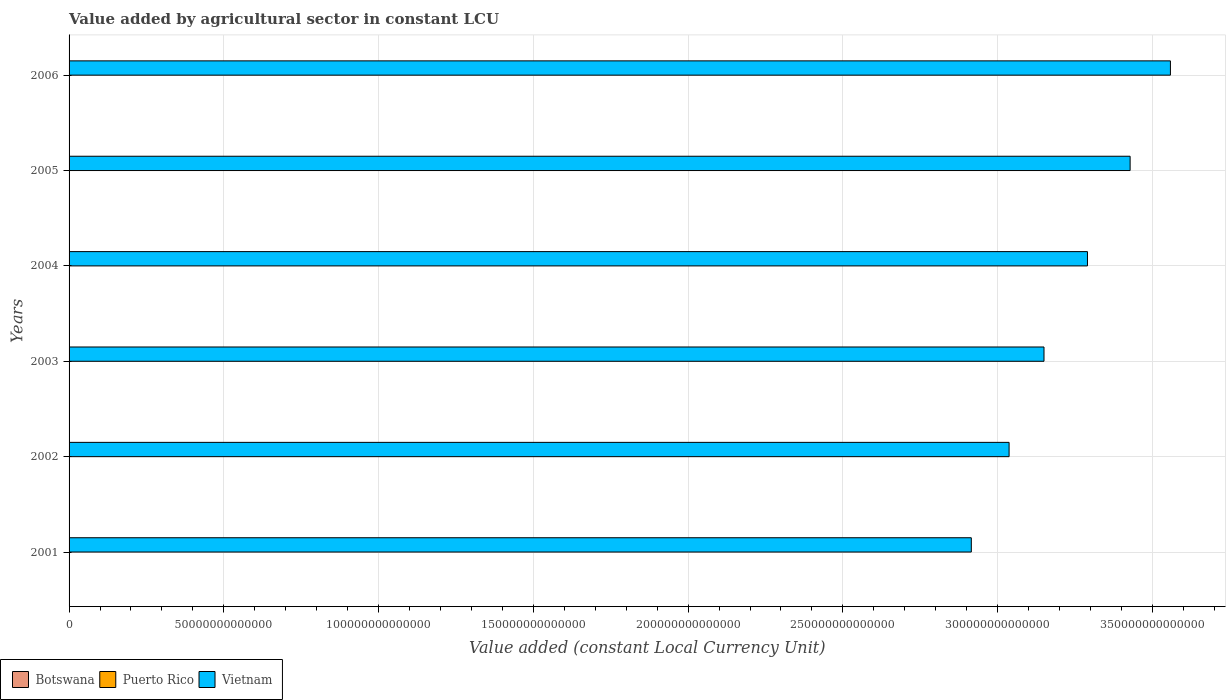Are the number of bars on each tick of the Y-axis equal?
Provide a short and direct response. Yes. What is the label of the 4th group of bars from the top?
Offer a very short reply. 2003. What is the value added by agricultural sector in Vietnam in 2006?
Give a very brief answer. 3.56e+14. Across all years, what is the maximum value added by agricultural sector in Vietnam?
Offer a very short reply. 3.56e+14. Across all years, what is the minimum value added by agricultural sector in Puerto Rico?
Your answer should be compact. 1.13e+08. In which year was the value added by agricultural sector in Vietnam maximum?
Provide a succinct answer. 2006. In which year was the value added by agricultural sector in Puerto Rico minimum?
Give a very brief answer. 2002. What is the total value added by agricultural sector in Vietnam in the graph?
Offer a very short reply. 1.94e+15. What is the difference between the value added by agricultural sector in Vietnam in 2004 and that in 2006?
Offer a terse response. -2.68e+13. What is the difference between the value added by agricultural sector in Puerto Rico in 2001 and the value added by agricultural sector in Vietnam in 2003?
Ensure brevity in your answer.  -3.15e+14. What is the average value added by agricultural sector in Puerto Rico per year?
Ensure brevity in your answer.  1.41e+08. In the year 2002, what is the difference between the value added by agricultural sector in Botswana and value added by agricultural sector in Puerto Rico?
Offer a terse response. 7.95e+08. In how many years, is the value added by agricultural sector in Botswana greater than 320000000000000 LCU?
Your answer should be compact. 0. What is the ratio of the value added by agricultural sector in Botswana in 2003 to that in 2006?
Your answer should be very brief. 0.9. Is the value added by agricultural sector in Botswana in 2003 less than that in 2004?
Ensure brevity in your answer.  Yes. What is the difference between the highest and the second highest value added by agricultural sector in Puerto Rico?
Make the answer very short. 1.14e+07. What is the difference between the highest and the lowest value added by agricultural sector in Puerto Rico?
Provide a short and direct response. 4.76e+07. Is the sum of the value added by agricultural sector in Puerto Rico in 2001 and 2005 greater than the maximum value added by agricultural sector in Botswana across all years?
Keep it short and to the point. No. What does the 1st bar from the top in 2006 represents?
Ensure brevity in your answer.  Vietnam. What does the 3rd bar from the bottom in 2004 represents?
Offer a terse response. Vietnam. How many bars are there?
Offer a very short reply. 18. How many years are there in the graph?
Your answer should be compact. 6. What is the difference between two consecutive major ticks on the X-axis?
Make the answer very short. 5.00e+13. Are the values on the major ticks of X-axis written in scientific E-notation?
Offer a terse response. No. Where does the legend appear in the graph?
Keep it short and to the point. Bottom left. How many legend labels are there?
Give a very brief answer. 3. How are the legend labels stacked?
Your answer should be very brief. Horizontal. What is the title of the graph?
Give a very brief answer. Value added by agricultural sector in constant LCU. Does "Burundi" appear as one of the legend labels in the graph?
Ensure brevity in your answer.  No. What is the label or title of the X-axis?
Offer a terse response. Value added (constant Local Currency Unit). What is the Value added (constant Local Currency Unit) of Botswana in 2001?
Make the answer very short. 1.14e+09. What is the Value added (constant Local Currency Unit) in Puerto Rico in 2001?
Provide a short and direct response. 1.41e+08. What is the Value added (constant Local Currency Unit) of Vietnam in 2001?
Keep it short and to the point. 2.92e+14. What is the Value added (constant Local Currency Unit) in Botswana in 2002?
Ensure brevity in your answer.  9.08e+08. What is the Value added (constant Local Currency Unit) of Puerto Rico in 2002?
Offer a very short reply. 1.13e+08. What is the Value added (constant Local Currency Unit) in Vietnam in 2002?
Give a very brief answer. 3.04e+14. What is the Value added (constant Local Currency Unit) of Botswana in 2003?
Your response must be concise. 1.09e+09. What is the Value added (constant Local Currency Unit) of Puerto Rico in 2003?
Offer a terse response. 1.30e+08. What is the Value added (constant Local Currency Unit) of Vietnam in 2003?
Your answer should be very brief. 3.15e+14. What is the Value added (constant Local Currency Unit) in Botswana in 2004?
Your answer should be very brief. 1.10e+09. What is the Value added (constant Local Currency Unit) of Puerto Rico in 2004?
Provide a short and direct response. 1.61e+08. What is the Value added (constant Local Currency Unit) of Vietnam in 2004?
Keep it short and to the point. 3.29e+14. What is the Value added (constant Local Currency Unit) in Botswana in 2005?
Provide a short and direct response. 1.07e+09. What is the Value added (constant Local Currency Unit) in Puerto Rico in 2005?
Make the answer very short. 1.49e+08. What is the Value added (constant Local Currency Unit) in Vietnam in 2005?
Provide a succinct answer. 3.43e+14. What is the Value added (constant Local Currency Unit) in Botswana in 2006?
Your answer should be compact. 1.21e+09. What is the Value added (constant Local Currency Unit) in Puerto Rico in 2006?
Give a very brief answer. 1.50e+08. What is the Value added (constant Local Currency Unit) in Vietnam in 2006?
Provide a short and direct response. 3.56e+14. Across all years, what is the maximum Value added (constant Local Currency Unit) of Botswana?
Make the answer very short. 1.21e+09. Across all years, what is the maximum Value added (constant Local Currency Unit) in Puerto Rico?
Your response must be concise. 1.61e+08. Across all years, what is the maximum Value added (constant Local Currency Unit) in Vietnam?
Offer a very short reply. 3.56e+14. Across all years, what is the minimum Value added (constant Local Currency Unit) of Botswana?
Provide a succinct answer. 9.08e+08. Across all years, what is the minimum Value added (constant Local Currency Unit) of Puerto Rico?
Your response must be concise. 1.13e+08. Across all years, what is the minimum Value added (constant Local Currency Unit) of Vietnam?
Offer a terse response. 2.92e+14. What is the total Value added (constant Local Currency Unit) in Botswana in the graph?
Provide a succinct answer. 6.52e+09. What is the total Value added (constant Local Currency Unit) of Puerto Rico in the graph?
Offer a terse response. 8.43e+08. What is the total Value added (constant Local Currency Unit) in Vietnam in the graph?
Provide a short and direct response. 1.94e+15. What is the difference between the Value added (constant Local Currency Unit) in Botswana in 2001 and that in 2002?
Provide a short and direct response. 2.34e+08. What is the difference between the Value added (constant Local Currency Unit) of Puerto Rico in 2001 and that in 2002?
Keep it short and to the point. 2.76e+07. What is the difference between the Value added (constant Local Currency Unit) of Vietnam in 2001 and that in 2002?
Offer a very short reply. -1.22e+13. What is the difference between the Value added (constant Local Currency Unit) of Botswana in 2001 and that in 2003?
Ensure brevity in your answer.  5.12e+07. What is the difference between the Value added (constant Local Currency Unit) in Puerto Rico in 2001 and that in 2003?
Provide a succinct answer. 1.14e+07. What is the difference between the Value added (constant Local Currency Unit) of Vietnam in 2001 and that in 2003?
Provide a short and direct response. -2.35e+13. What is the difference between the Value added (constant Local Currency Unit) of Botswana in 2001 and that in 2004?
Offer a very short reply. 4.60e+07. What is the difference between the Value added (constant Local Currency Unit) of Puerto Rico in 2001 and that in 2004?
Provide a short and direct response. -2.00e+07. What is the difference between the Value added (constant Local Currency Unit) in Vietnam in 2001 and that in 2004?
Ensure brevity in your answer.  -3.75e+13. What is the difference between the Value added (constant Local Currency Unit) in Botswana in 2001 and that in 2005?
Give a very brief answer. 7.35e+07. What is the difference between the Value added (constant Local Currency Unit) of Puerto Rico in 2001 and that in 2005?
Provide a short and direct response. -7.62e+06. What is the difference between the Value added (constant Local Currency Unit) of Vietnam in 2001 and that in 2005?
Your response must be concise. -5.13e+13. What is the difference between the Value added (constant Local Currency Unit) in Botswana in 2001 and that in 2006?
Make the answer very short. -6.89e+07. What is the difference between the Value added (constant Local Currency Unit) in Puerto Rico in 2001 and that in 2006?
Ensure brevity in your answer.  -8.58e+06. What is the difference between the Value added (constant Local Currency Unit) of Vietnam in 2001 and that in 2006?
Provide a short and direct response. -6.43e+13. What is the difference between the Value added (constant Local Currency Unit) of Botswana in 2002 and that in 2003?
Offer a terse response. -1.83e+08. What is the difference between the Value added (constant Local Currency Unit) in Puerto Rico in 2002 and that in 2003?
Provide a short and direct response. -1.62e+07. What is the difference between the Value added (constant Local Currency Unit) of Vietnam in 2002 and that in 2003?
Make the answer very short. -1.13e+13. What is the difference between the Value added (constant Local Currency Unit) in Botswana in 2002 and that in 2004?
Keep it short and to the point. -1.88e+08. What is the difference between the Value added (constant Local Currency Unit) of Puerto Rico in 2002 and that in 2004?
Ensure brevity in your answer.  -4.76e+07. What is the difference between the Value added (constant Local Currency Unit) of Vietnam in 2002 and that in 2004?
Make the answer very short. -2.53e+13. What is the difference between the Value added (constant Local Currency Unit) of Botswana in 2002 and that in 2005?
Provide a short and direct response. -1.60e+08. What is the difference between the Value added (constant Local Currency Unit) in Puerto Rico in 2002 and that in 2005?
Make the answer very short. -3.53e+07. What is the difference between the Value added (constant Local Currency Unit) in Vietnam in 2002 and that in 2005?
Keep it short and to the point. -3.91e+13. What is the difference between the Value added (constant Local Currency Unit) in Botswana in 2002 and that in 2006?
Ensure brevity in your answer.  -3.03e+08. What is the difference between the Value added (constant Local Currency Unit) of Puerto Rico in 2002 and that in 2006?
Offer a terse response. -3.62e+07. What is the difference between the Value added (constant Local Currency Unit) of Vietnam in 2002 and that in 2006?
Make the answer very short. -5.21e+13. What is the difference between the Value added (constant Local Currency Unit) in Botswana in 2003 and that in 2004?
Provide a succinct answer. -5.15e+06. What is the difference between the Value added (constant Local Currency Unit) of Puerto Rico in 2003 and that in 2004?
Offer a terse response. -3.14e+07. What is the difference between the Value added (constant Local Currency Unit) in Vietnam in 2003 and that in 2004?
Your answer should be very brief. -1.40e+13. What is the difference between the Value added (constant Local Currency Unit) in Botswana in 2003 and that in 2005?
Make the answer very short. 2.23e+07. What is the difference between the Value added (constant Local Currency Unit) of Puerto Rico in 2003 and that in 2005?
Provide a succinct answer. -1.91e+07. What is the difference between the Value added (constant Local Currency Unit) in Vietnam in 2003 and that in 2005?
Offer a terse response. -2.78e+13. What is the difference between the Value added (constant Local Currency Unit) in Botswana in 2003 and that in 2006?
Provide a succinct answer. -1.20e+08. What is the difference between the Value added (constant Local Currency Unit) in Puerto Rico in 2003 and that in 2006?
Your response must be concise. -2.00e+07. What is the difference between the Value added (constant Local Currency Unit) in Vietnam in 2003 and that in 2006?
Make the answer very short. -4.08e+13. What is the difference between the Value added (constant Local Currency Unit) of Botswana in 2004 and that in 2005?
Provide a succinct answer. 2.74e+07. What is the difference between the Value added (constant Local Currency Unit) of Puerto Rico in 2004 and that in 2005?
Provide a succinct answer. 1.24e+07. What is the difference between the Value added (constant Local Currency Unit) of Vietnam in 2004 and that in 2005?
Give a very brief answer. -1.38e+13. What is the difference between the Value added (constant Local Currency Unit) in Botswana in 2004 and that in 2006?
Provide a succinct answer. -1.15e+08. What is the difference between the Value added (constant Local Currency Unit) of Puerto Rico in 2004 and that in 2006?
Your answer should be compact. 1.14e+07. What is the difference between the Value added (constant Local Currency Unit) of Vietnam in 2004 and that in 2006?
Provide a short and direct response. -2.68e+13. What is the difference between the Value added (constant Local Currency Unit) of Botswana in 2005 and that in 2006?
Your answer should be very brief. -1.42e+08. What is the difference between the Value added (constant Local Currency Unit) of Puerto Rico in 2005 and that in 2006?
Provide a succinct answer. -9.53e+05. What is the difference between the Value added (constant Local Currency Unit) of Vietnam in 2005 and that in 2006?
Keep it short and to the point. -1.30e+13. What is the difference between the Value added (constant Local Currency Unit) in Botswana in 2001 and the Value added (constant Local Currency Unit) in Puerto Rico in 2002?
Offer a very short reply. 1.03e+09. What is the difference between the Value added (constant Local Currency Unit) in Botswana in 2001 and the Value added (constant Local Currency Unit) in Vietnam in 2002?
Keep it short and to the point. -3.04e+14. What is the difference between the Value added (constant Local Currency Unit) of Puerto Rico in 2001 and the Value added (constant Local Currency Unit) of Vietnam in 2002?
Ensure brevity in your answer.  -3.04e+14. What is the difference between the Value added (constant Local Currency Unit) in Botswana in 2001 and the Value added (constant Local Currency Unit) in Puerto Rico in 2003?
Provide a short and direct response. 1.01e+09. What is the difference between the Value added (constant Local Currency Unit) in Botswana in 2001 and the Value added (constant Local Currency Unit) in Vietnam in 2003?
Keep it short and to the point. -3.15e+14. What is the difference between the Value added (constant Local Currency Unit) in Puerto Rico in 2001 and the Value added (constant Local Currency Unit) in Vietnam in 2003?
Provide a succinct answer. -3.15e+14. What is the difference between the Value added (constant Local Currency Unit) in Botswana in 2001 and the Value added (constant Local Currency Unit) in Puerto Rico in 2004?
Your answer should be compact. 9.81e+08. What is the difference between the Value added (constant Local Currency Unit) in Botswana in 2001 and the Value added (constant Local Currency Unit) in Vietnam in 2004?
Provide a succinct answer. -3.29e+14. What is the difference between the Value added (constant Local Currency Unit) in Puerto Rico in 2001 and the Value added (constant Local Currency Unit) in Vietnam in 2004?
Your response must be concise. -3.29e+14. What is the difference between the Value added (constant Local Currency Unit) of Botswana in 2001 and the Value added (constant Local Currency Unit) of Puerto Rico in 2005?
Offer a terse response. 9.93e+08. What is the difference between the Value added (constant Local Currency Unit) of Botswana in 2001 and the Value added (constant Local Currency Unit) of Vietnam in 2005?
Keep it short and to the point. -3.43e+14. What is the difference between the Value added (constant Local Currency Unit) of Puerto Rico in 2001 and the Value added (constant Local Currency Unit) of Vietnam in 2005?
Keep it short and to the point. -3.43e+14. What is the difference between the Value added (constant Local Currency Unit) in Botswana in 2001 and the Value added (constant Local Currency Unit) in Puerto Rico in 2006?
Offer a very short reply. 9.92e+08. What is the difference between the Value added (constant Local Currency Unit) of Botswana in 2001 and the Value added (constant Local Currency Unit) of Vietnam in 2006?
Ensure brevity in your answer.  -3.56e+14. What is the difference between the Value added (constant Local Currency Unit) in Puerto Rico in 2001 and the Value added (constant Local Currency Unit) in Vietnam in 2006?
Ensure brevity in your answer.  -3.56e+14. What is the difference between the Value added (constant Local Currency Unit) of Botswana in 2002 and the Value added (constant Local Currency Unit) of Puerto Rico in 2003?
Offer a terse response. 7.78e+08. What is the difference between the Value added (constant Local Currency Unit) in Botswana in 2002 and the Value added (constant Local Currency Unit) in Vietnam in 2003?
Provide a succinct answer. -3.15e+14. What is the difference between the Value added (constant Local Currency Unit) of Puerto Rico in 2002 and the Value added (constant Local Currency Unit) of Vietnam in 2003?
Provide a short and direct response. -3.15e+14. What is the difference between the Value added (constant Local Currency Unit) in Botswana in 2002 and the Value added (constant Local Currency Unit) in Puerto Rico in 2004?
Ensure brevity in your answer.  7.47e+08. What is the difference between the Value added (constant Local Currency Unit) of Botswana in 2002 and the Value added (constant Local Currency Unit) of Vietnam in 2004?
Your response must be concise. -3.29e+14. What is the difference between the Value added (constant Local Currency Unit) of Puerto Rico in 2002 and the Value added (constant Local Currency Unit) of Vietnam in 2004?
Provide a succinct answer. -3.29e+14. What is the difference between the Value added (constant Local Currency Unit) of Botswana in 2002 and the Value added (constant Local Currency Unit) of Puerto Rico in 2005?
Keep it short and to the point. 7.59e+08. What is the difference between the Value added (constant Local Currency Unit) of Botswana in 2002 and the Value added (constant Local Currency Unit) of Vietnam in 2005?
Provide a succinct answer. -3.43e+14. What is the difference between the Value added (constant Local Currency Unit) in Puerto Rico in 2002 and the Value added (constant Local Currency Unit) in Vietnam in 2005?
Provide a succinct answer. -3.43e+14. What is the difference between the Value added (constant Local Currency Unit) of Botswana in 2002 and the Value added (constant Local Currency Unit) of Puerto Rico in 2006?
Offer a terse response. 7.58e+08. What is the difference between the Value added (constant Local Currency Unit) in Botswana in 2002 and the Value added (constant Local Currency Unit) in Vietnam in 2006?
Provide a succinct answer. -3.56e+14. What is the difference between the Value added (constant Local Currency Unit) of Puerto Rico in 2002 and the Value added (constant Local Currency Unit) of Vietnam in 2006?
Your answer should be very brief. -3.56e+14. What is the difference between the Value added (constant Local Currency Unit) in Botswana in 2003 and the Value added (constant Local Currency Unit) in Puerto Rico in 2004?
Keep it short and to the point. 9.30e+08. What is the difference between the Value added (constant Local Currency Unit) in Botswana in 2003 and the Value added (constant Local Currency Unit) in Vietnam in 2004?
Give a very brief answer. -3.29e+14. What is the difference between the Value added (constant Local Currency Unit) in Puerto Rico in 2003 and the Value added (constant Local Currency Unit) in Vietnam in 2004?
Make the answer very short. -3.29e+14. What is the difference between the Value added (constant Local Currency Unit) in Botswana in 2003 and the Value added (constant Local Currency Unit) in Puerto Rico in 2005?
Your answer should be compact. 9.42e+08. What is the difference between the Value added (constant Local Currency Unit) in Botswana in 2003 and the Value added (constant Local Currency Unit) in Vietnam in 2005?
Your answer should be compact. -3.43e+14. What is the difference between the Value added (constant Local Currency Unit) of Puerto Rico in 2003 and the Value added (constant Local Currency Unit) of Vietnam in 2005?
Keep it short and to the point. -3.43e+14. What is the difference between the Value added (constant Local Currency Unit) in Botswana in 2003 and the Value added (constant Local Currency Unit) in Puerto Rico in 2006?
Your response must be concise. 9.41e+08. What is the difference between the Value added (constant Local Currency Unit) in Botswana in 2003 and the Value added (constant Local Currency Unit) in Vietnam in 2006?
Your answer should be compact. -3.56e+14. What is the difference between the Value added (constant Local Currency Unit) of Puerto Rico in 2003 and the Value added (constant Local Currency Unit) of Vietnam in 2006?
Provide a short and direct response. -3.56e+14. What is the difference between the Value added (constant Local Currency Unit) of Botswana in 2004 and the Value added (constant Local Currency Unit) of Puerto Rico in 2005?
Give a very brief answer. 9.47e+08. What is the difference between the Value added (constant Local Currency Unit) of Botswana in 2004 and the Value added (constant Local Currency Unit) of Vietnam in 2005?
Give a very brief answer. -3.43e+14. What is the difference between the Value added (constant Local Currency Unit) in Puerto Rico in 2004 and the Value added (constant Local Currency Unit) in Vietnam in 2005?
Your response must be concise. -3.43e+14. What is the difference between the Value added (constant Local Currency Unit) in Botswana in 2004 and the Value added (constant Local Currency Unit) in Puerto Rico in 2006?
Keep it short and to the point. 9.46e+08. What is the difference between the Value added (constant Local Currency Unit) of Botswana in 2004 and the Value added (constant Local Currency Unit) of Vietnam in 2006?
Your response must be concise. -3.56e+14. What is the difference between the Value added (constant Local Currency Unit) of Puerto Rico in 2004 and the Value added (constant Local Currency Unit) of Vietnam in 2006?
Offer a very short reply. -3.56e+14. What is the difference between the Value added (constant Local Currency Unit) in Botswana in 2005 and the Value added (constant Local Currency Unit) in Puerto Rico in 2006?
Provide a short and direct response. 9.19e+08. What is the difference between the Value added (constant Local Currency Unit) in Botswana in 2005 and the Value added (constant Local Currency Unit) in Vietnam in 2006?
Offer a terse response. -3.56e+14. What is the difference between the Value added (constant Local Currency Unit) in Puerto Rico in 2005 and the Value added (constant Local Currency Unit) in Vietnam in 2006?
Your answer should be very brief. -3.56e+14. What is the average Value added (constant Local Currency Unit) in Botswana per year?
Your response must be concise. 1.09e+09. What is the average Value added (constant Local Currency Unit) in Puerto Rico per year?
Your response must be concise. 1.41e+08. What is the average Value added (constant Local Currency Unit) in Vietnam per year?
Your answer should be compact. 3.23e+14. In the year 2001, what is the difference between the Value added (constant Local Currency Unit) in Botswana and Value added (constant Local Currency Unit) in Puerto Rico?
Your answer should be very brief. 1.00e+09. In the year 2001, what is the difference between the Value added (constant Local Currency Unit) of Botswana and Value added (constant Local Currency Unit) of Vietnam?
Keep it short and to the point. -2.92e+14. In the year 2001, what is the difference between the Value added (constant Local Currency Unit) in Puerto Rico and Value added (constant Local Currency Unit) in Vietnam?
Keep it short and to the point. -2.92e+14. In the year 2002, what is the difference between the Value added (constant Local Currency Unit) in Botswana and Value added (constant Local Currency Unit) in Puerto Rico?
Provide a short and direct response. 7.95e+08. In the year 2002, what is the difference between the Value added (constant Local Currency Unit) in Botswana and Value added (constant Local Currency Unit) in Vietnam?
Make the answer very short. -3.04e+14. In the year 2002, what is the difference between the Value added (constant Local Currency Unit) of Puerto Rico and Value added (constant Local Currency Unit) of Vietnam?
Provide a short and direct response. -3.04e+14. In the year 2003, what is the difference between the Value added (constant Local Currency Unit) of Botswana and Value added (constant Local Currency Unit) of Puerto Rico?
Provide a short and direct response. 9.61e+08. In the year 2003, what is the difference between the Value added (constant Local Currency Unit) of Botswana and Value added (constant Local Currency Unit) of Vietnam?
Ensure brevity in your answer.  -3.15e+14. In the year 2003, what is the difference between the Value added (constant Local Currency Unit) of Puerto Rico and Value added (constant Local Currency Unit) of Vietnam?
Provide a short and direct response. -3.15e+14. In the year 2004, what is the difference between the Value added (constant Local Currency Unit) in Botswana and Value added (constant Local Currency Unit) in Puerto Rico?
Keep it short and to the point. 9.35e+08. In the year 2004, what is the difference between the Value added (constant Local Currency Unit) in Botswana and Value added (constant Local Currency Unit) in Vietnam?
Provide a succinct answer. -3.29e+14. In the year 2004, what is the difference between the Value added (constant Local Currency Unit) in Puerto Rico and Value added (constant Local Currency Unit) in Vietnam?
Your answer should be compact. -3.29e+14. In the year 2005, what is the difference between the Value added (constant Local Currency Unit) in Botswana and Value added (constant Local Currency Unit) in Puerto Rico?
Your answer should be compact. 9.20e+08. In the year 2005, what is the difference between the Value added (constant Local Currency Unit) in Botswana and Value added (constant Local Currency Unit) in Vietnam?
Ensure brevity in your answer.  -3.43e+14. In the year 2005, what is the difference between the Value added (constant Local Currency Unit) in Puerto Rico and Value added (constant Local Currency Unit) in Vietnam?
Your answer should be very brief. -3.43e+14. In the year 2006, what is the difference between the Value added (constant Local Currency Unit) of Botswana and Value added (constant Local Currency Unit) of Puerto Rico?
Your answer should be very brief. 1.06e+09. In the year 2006, what is the difference between the Value added (constant Local Currency Unit) in Botswana and Value added (constant Local Currency Unit) in Vietnam?
Your answer should be compact. -3.56e+14. In the year 2006, what is the difference between the Value added (constant Local Currency Unit) of Puerto Rico and Value added (constant Local Currency Unit) of Vietnam?
Make the answer very short. -3.56e+14. What is the ratio of the Value added (constant Local Currency Unit) of Botswana in 2001 to that in 2002?
Your answer should be compact. 1.26. What is the ratio of the Value added (constant Local Currency Unit) in Puerto Rico in 2001 to that in 2002?
Offer a terse response. 1.24. What is the ratio of the Value added (constant Local Currency Unit) in Vietnam in 2001 to that in 2002?
Offer a terse response. 0.96. What is the ratio of the Value added (constant Local Currency Unit) of Botswana in 2001 to that in 2003?
Offer a very short reply. 1.05. What is the ratio of the Value added (constant Local Currency Unit) in Puerto Rico in 2001 to that in 2003?
Provide a short and direct response. 1.09. What is the ratio of the Value added (constant Local Currency Unit) of Vietnam in 2001 to that in 2003?
Offer a terse response. 0.93. What is the ratio of the Value added (constant Local Currency Unit) in Botswana in 2001 to that in 2004?
Ensure brevity in your answer.  1.04. What is the ratio of the Value added (constant Local Currency Unit) in Puerto Rico in 2001 to that in 2004?
Offer a terse response. 0.88. What is the ratio of the Value added (constant Local Currency Unit) in Vietnam in 2001 to that in 2004?
Provide a succinct answer. 0.89. What is the ratio of the Value added (constant Local Currency Unit) in Botswana in 2001 to that in 2005?
Offer a terse response. 1.07. What is the ratio of the Value added (constant Local Currency Unit) in Puerto Rico in 2001 to that in 2005?
Provide a succinct answer. 0.95. What is the ratio of the Value added (constant Local Currency Unit) in Vietnam in 2001 to that in 2005?
Offer a terse response. 0.85. What is the ratio of the Value added (constant Local Currency Unit) of Botswana in 2001 to that in 2006?
Provide a short and direct response. 0.94. What is the ratio of the Value added (constant Local Currency Unit) of Puerto Rico in 2001 to that in 2006?
Your response must be concise. 0.94. What is the ratio of the Value added (constant Local Currency Unit) in Vietnam in 2001 to that in 2006?
Make the answer very short. 0.82. What is the ratio of the Value added (constant Local Currency Unit) in Botswana in 2002 to that in 2003?
Your answer should be very brief. 0.83. What is the ratio of the Value added (constant Local Currency Unit) of Puerto Rico in 2002 to that in 2003?
Make the answer very short. 0.88. What is the ratio of the Value added (constant Local Currency Unit) of Vietnam in 2002 to that in 2003?
Provide a succinct answer. 0.96. What is the ratio of the Value added (constant Local Currency Unit) in Botswana in 2002 to that in 2004?
Provide a short and direct response. 0.83. What is the ratio of the Value added (constant Local Currency Unit) in Puerto Rico in 2002 to that in 2004?
Your answer should be compact. 0.7. What is the ratio of the Value added (constant Local Currency Unit) of Vietnam in 2002 to that in 2004?
Keep it short and to the point. 0.92. What is the ratio of the Value added (constant Local Currency Unit) in Botswana in 2002 to that in 2005?
Provide a succinct answer. 0.85. What is the ratio of the Value added (constant Local Currency Unit) in Puerto Rico in 2002 to that in 2005?
Your response must be concise. 0.76. What is the ratio of the Value added (constant Local Currency Unit) in Vietnam in 2002 to that in 2005?
Provide a succinct answer. 0.89. What is the ratio of the Value added (constant Local Currency Unit) of Botswana in 2002 to that in 2006?
Offer a very short reply. 0.75. What is the ratio of the Value added (constant Local Currency Unit) of Puerto Rico in 2002 to that in 2006?
Make the answer very short. 0.76. What is the ratio of the Value added (constant Local Currency Unit) in Vietnam in 2002 to that in 2006?
Keep it short and to the point. 0.85. What is the ratio of the Value added (constant Local Currency Unit) of Puerto Rico in 2003 to that in 2004?
Your answer should be very brief. 0.8. What is the ratio of the Value added (constant Local Currency Unit) of Vietnam in 2003 to that in 2004?
Your response must be concise. 0.96. What is the ratio of the Value added (constant Local Currency Unit) of Botswana in 2003 to that in 2005?
Your answer should be very brief. 1.02. What is the ratio of the Value added (constant Local Currency Unit) in Puerto Rico in 2003 to that in 2005?
Offer a very short reply. 0.87. What is the ratio of the Value added (constant Local Currency Unit) in Vietnam in 2003 to that in 2005?
Ensure brevity in your answer.  0.92. What is the ratio of the Value added (constant Local Currency Unit) of Botswana in 2003 to that in 2006?
Provide a succinct answer. 0.9. What is the ratio of the Value added (constant Local Currency Unit) of Puerto Rico in 2003 to that in 2006?
Keep it short and to the point. 0.87. What is the ratio of the Value added (constant Local Currency Unit) in Vietnam in 2003 to that in 2006?
Provide a short and direct response. 0.89. What is the ratio of the Value added (constant Local Currency Unit) of Botswana in 2004 to that in 2005?
Provide a succinct answer. 1.03. What is the ratio of the Value added (constant Local Currency Unit) in Puerto Rico in 2004 to that in 2005?
Provide a short and direct response. 1.08. What is the ratio of the Value added (constant Local Currency Unit) in Vietnam in 2004 to that in 2005?
Make the answer very short. 0.96. What is the ratio of the Value added (constant Local Currency Unit) in Botswana in 2004 to that in 2006?
Your answer should be compact. 0.91. What is the ratio of the Value added (constant Local Currency Unit) of Puerto Rico in 2004 to that in 2006?
Provide a succinct answer. 1.08. What is the ratio of the Value added (constant Local Currency Unit) of Vietnam in 2004 to that in 2006?
Provide a succinct answer. 0.92. What is the ratio of the Value added (constant Local Currency Unit) of Botswana in 2005 to that in 2006?
Provide a succinct answer. 0.88. What is the ratio of the Value added (constant Local Currency Unit) of Puerto Rico in 2005 to that in 2006?
Keep it short and to the point. 0.99. What is the ratio of the Value added (constant Local Currency Unit) of Vietnam in 2005 to that in 2006?
Provide a succinct answer. 0.96. What is the difference between the highest and the second highest Value added (constant Local Currency Unit) of Botswana?
Provide a short and direct response. 6.89e+07. What is the difference between the highest and the second highest Value added (constant Local Currency Unit) of Puerto Rico?
Give a very brief answer. 1.14e+07. What is the difference between the highest and the second highest Value added (constant Local Currency Unit) in Vietnam?
Provide a short and direct response. 1.30e+13. What is the difference between the highest and the lowest Value added (constant Local Currency Unit) of Botswana?
Keep it short and to the point. 3.03e+08. What is the difference between the highest and the lowest Value added (constant Local Currency Unit) of Puerto Rico?
Keep it short and to the point. 4.76e+07. What is the difference between the highest and the lowest Value added (constant Local Currency Unit) of Vietnam?
Your answer should be very brief. 6.43e+13. 